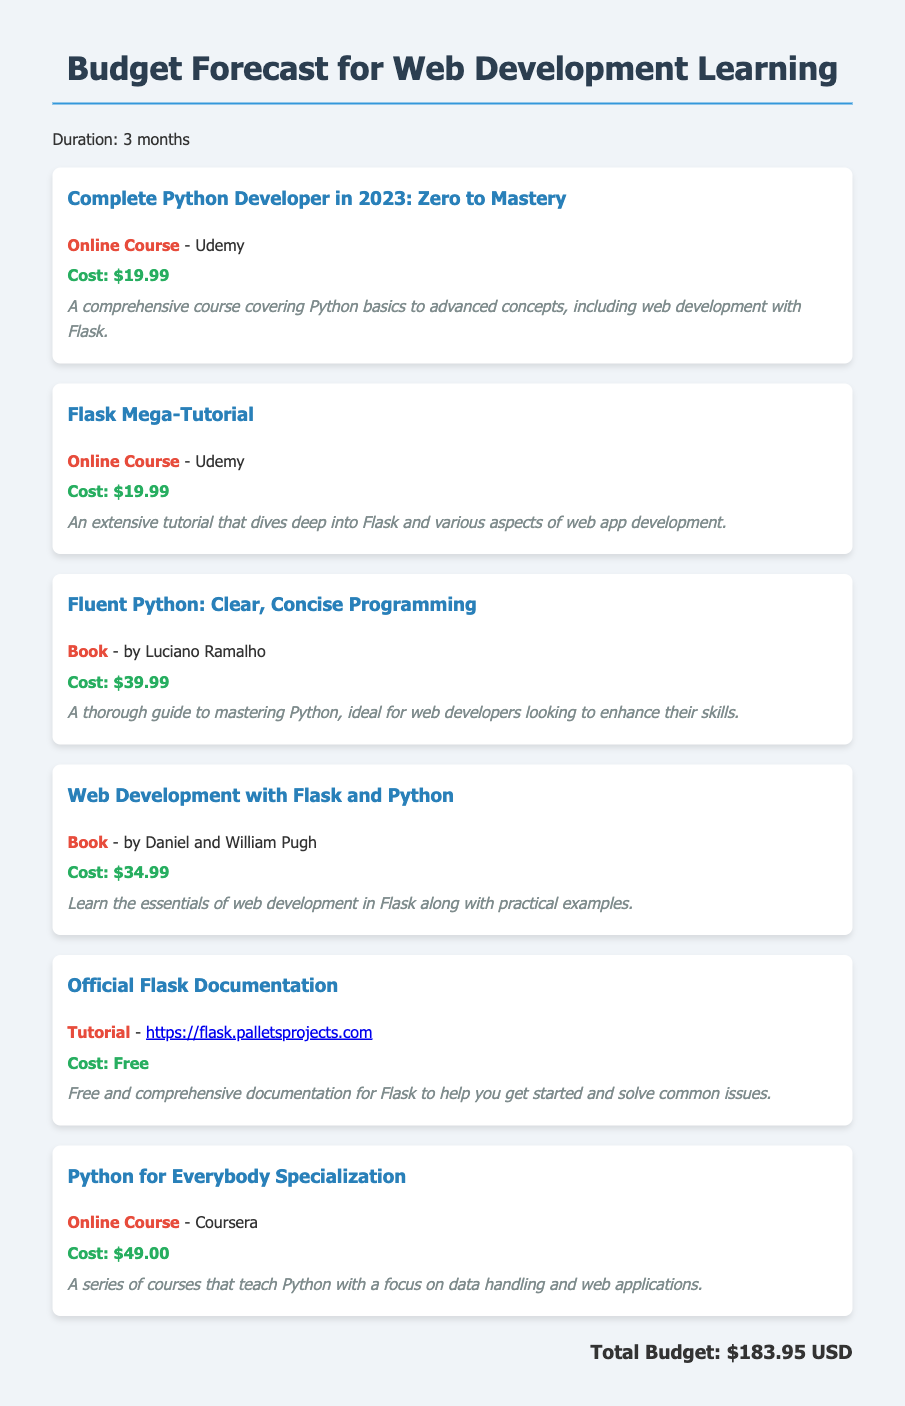What is the total budget? The total budget is explicitly stated in the document, totaling all specified costs, which adds up to $183.95.
Answer: $183.95 How many online courses are listed? The document contains multiple resources, and by counting the online courses, we find there are three specified in the document.
Answer: Three What is the cost of the Fluent Python book? The document specifies the cost of the Fluent Python book, which is listed as $39.99.
Answer: $39.99 What is the title of the free tutorial? The document includes information about a free tutorial, specifically naming the Official Flask Documentation.
Answer: Official Flask Documentation Which platform offers the Complete Python Developer course? The document states that the Complete Python Developer course is available on Udemy, as mentioned in the resource description.
Answer: Udemy How much does the Python for Everybody Specialization cost? The document lists the cost for the Python for Everybody Specialization, which is stated as $49.00.
Answer: $49.00 How many resources listed are books? By reviewing the resources outlined in the document, we can identify two of them are categorized as books.
Answer: Two What kind of resource is the Flask Mega-Tutorial? The document classifies the Flask Mega-Tutorial as an online course, as detailed in its description.
Answer: Online Course 